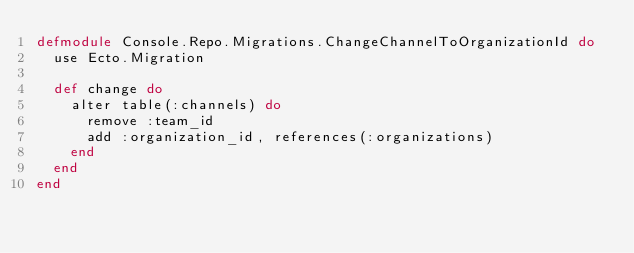<code> <loc_0><loc_0><loc_500><loc_500><_Elixir_>defmodule Console.Repo.Migrations.ChangeChannelToOrganizationId do
  use Ecto.Migration

  def change do
    alter table(:channels) do
      remove :team_id
      add :organization_id, references(:organizations)
    end
  end
end
</code> 